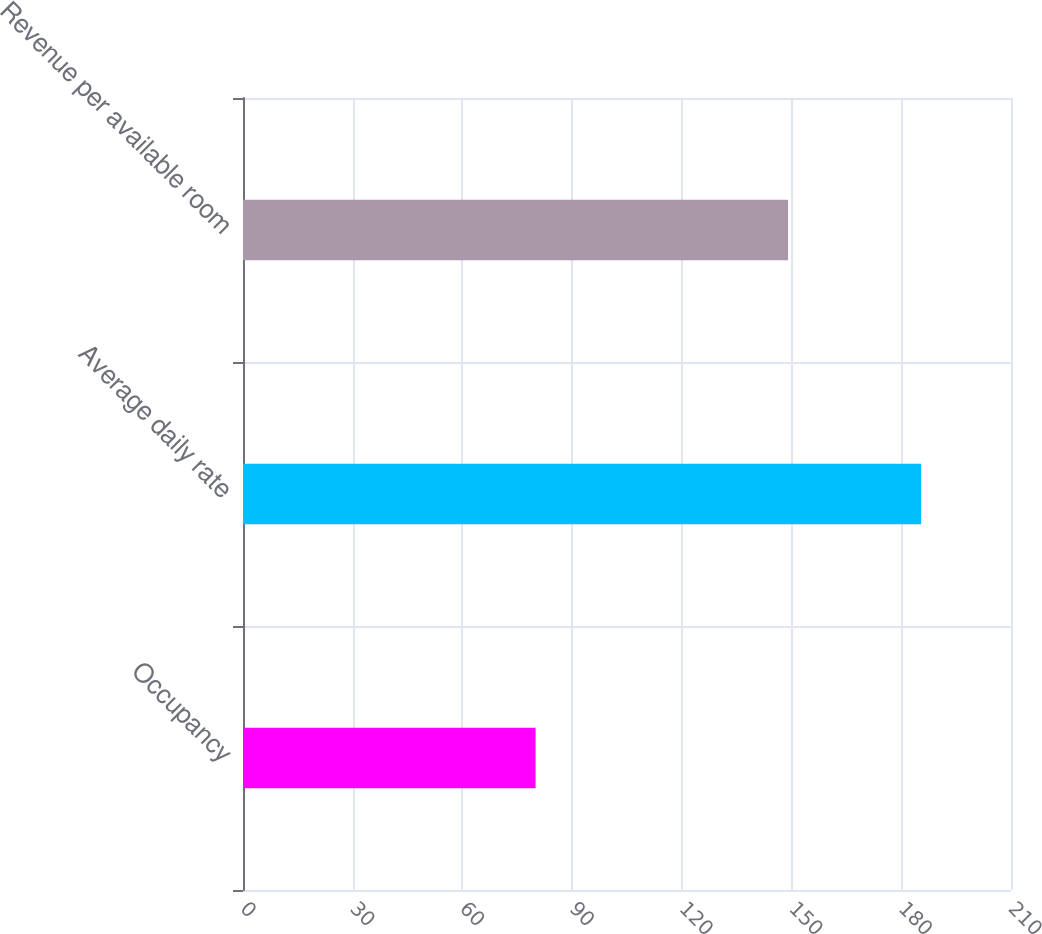<chart> <loc_0><loc_0><loc_500><loc_500><bar_chart><fcel>Occupancy<fcel>Average daily rate<fcel>Revenue per available room<nl><fcel>80<fcel>185.42<fcel>149.04<nl></chart> 